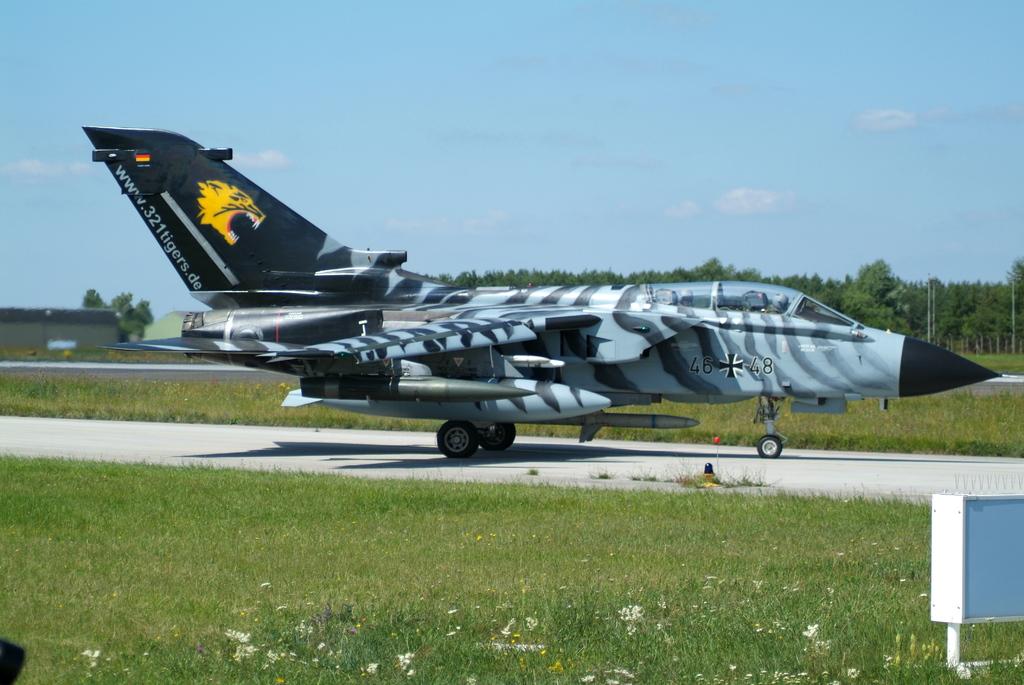What's the color of the url text?
Provide a short and direct response. Answering does not require reading text in the image. What is the name of the website?
Your answer should be very brief. Www.321tigers.de. 